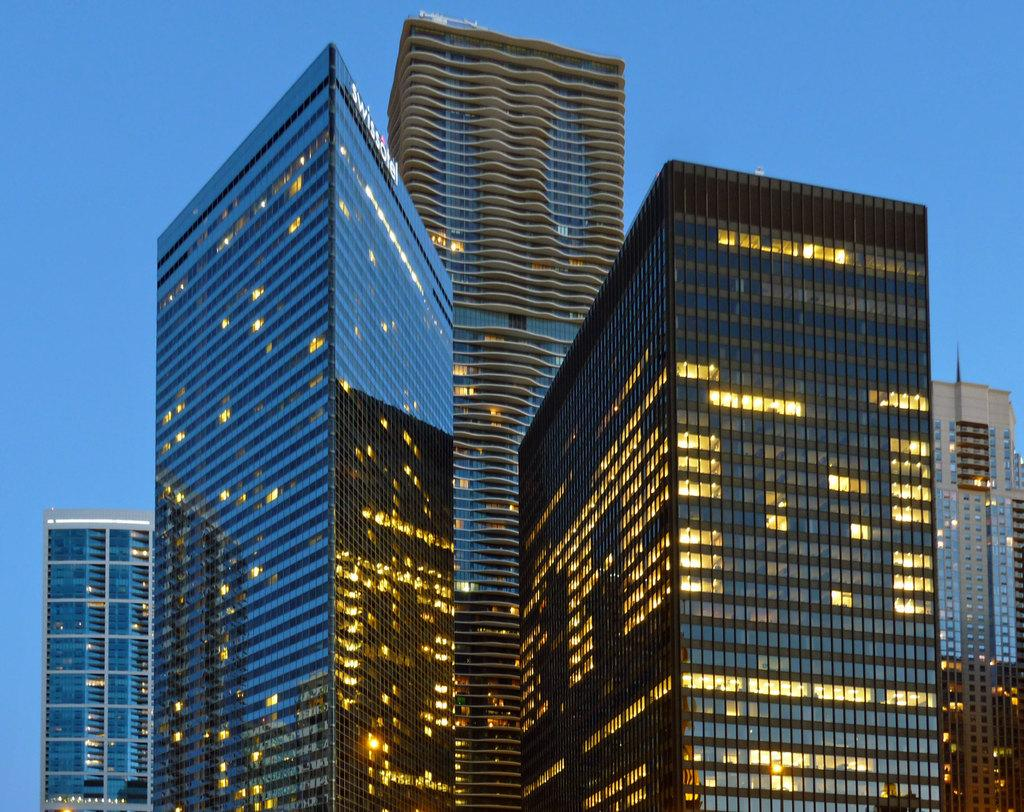What type of buildings are visible in the image? The buildings with glass are visible in the image. What can be seen in the background of the image? The background of the image includes a blue sky. What type of wire is being used to hold up the sidewalk in the image? There is no sidewalk or wire present in the image. What town is depicted in the image? The image does not depict a specific town; it only shows buildings with glass and a blue sky in the background. 